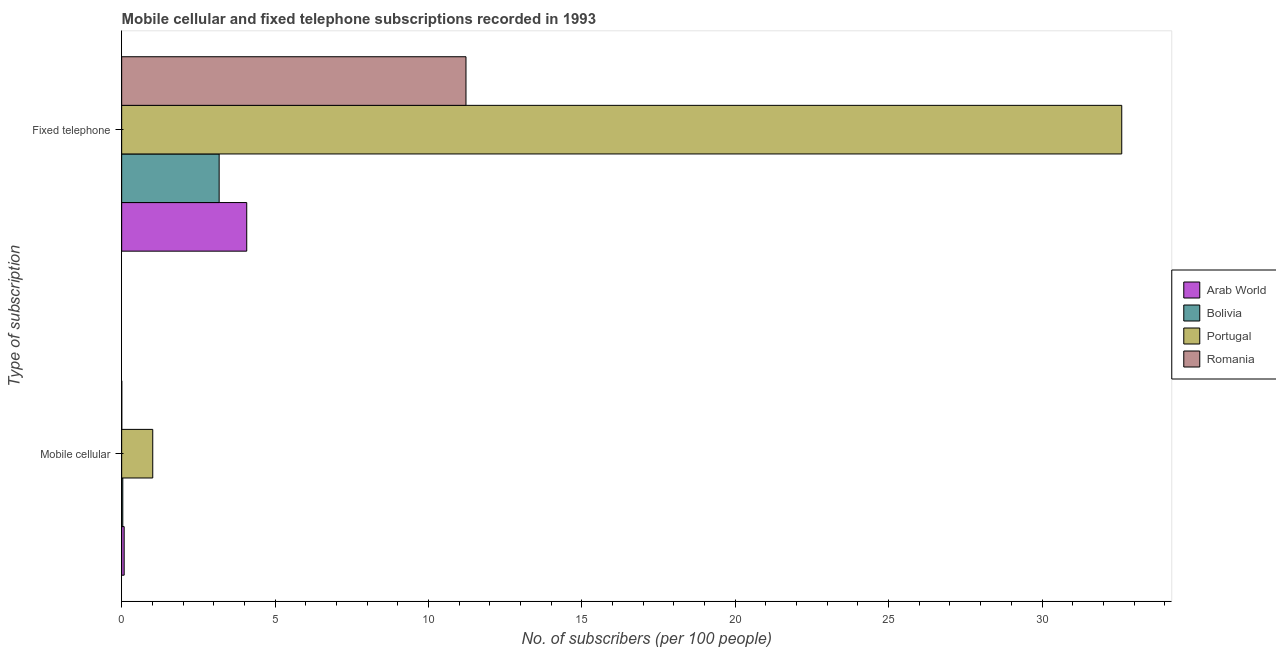Are the number of bars per tick equal to the number of legend labels?
Your response must be concise. Yes. How many bars are there on the 2nd tick from the bottom?
Provide a succinct answer. 4. What is the label of the 2nd group of bars from the top?
Your answer should be compact. Mobile cellular. What is the number of mobile cellular subscribers in Portugal?
Offer a terse response. 1.01. Across all countries, what is the maximum number of fixed telephone subscribers?
Give a very brief answer. 32.6. Across all countries, what is the minimum number of mobile cellular subscribers?
Give a very brief answer. 0. In which country was the number of fixed telephone subscribers maximum?
Give a very brief answer. Portugal. In which country was the number of mobile cellular subscribers minimum?
Ensure brevity in your answer.  Romania. What is the total number of fixed telephone subscribers in the graph?
Your answer should be very brief. 51.08. What is the difference between the number of mobile cellular subscribers in Bolivia and that in Portugal?
Keep it short and to the point. -0.98. What is the difference between the number of fixed telephone subscribers in Portugal and the number of mobile cellular subscribers in Arab World?
Give a very brief answer. 32.52. What is the average number of fixed telephone subscribers per country?
Provide a short and direct response. 12.77. What is the difference between the number of mobile cellular subscribers and number of fixed telephone subscribers in Romania?
Offer a very short reply. -11.22. What is the ratio of the number of fixed telephone subscribers in Bolivia to that in Portugal?
Offer a very short reply. 0.1. Is the number of mobile cellular subscribers in Bolivia less than that in Romania?
Make the answer very short. No. In how many countries, is the number of fixed telephone subscribers greater than the average number of fixed telephone subscribers taken over all countries?
Ensure brevity in your answer.  1. What does the 2nd bar from the top in Fixed telephone represents?
Provide a short and direct response. Portugal. What does the 4th bar from the bottom in Fixed telephone represents?
Ensure brevity in your answer.  Romania. How many bars are there?
Make the answer very short. 8. Are all the bars in the graph horizontal?
Provide a succinct answer. Yes. How many countries are there in the graph?
Your answer should be compact. 4. What is the difference between two consecutive major ticks on the X-axis?
Give a very brief answer. 5. Does the graph contain any zero values?
Give a very brief answer. No. Does the graph contain grids?
Keep it short and to the point. No. Where does the legend appear in the graph?
Provide a succinct answer. Center right. What is the title of the graph?
Your answer should be compact. Mobile cellular and fixed telephone subscriptions recorded in 1993. What is the label or title of the X-axis?
Give a very brief answer. No. of subscribers (per 100 people). What is the label or title of the Y-axis?
Your answer should be compact. Type of subscription. What is the No. of subscribers (per 100 people) of Arab World in Mobile cellular?
Offer a terse response. 0.08. What is the No. of subscribers (per 100 people) of Bolivia in Mobile cellular?
Provide a short and direct response. 0.04. What is the No. of subscribers (per 100 people) of Portugal in Mobile cellular?
Keep it short and to the point. 1.01. What is the No. of subscribers (per 100 people) in Romania in Mobile cellular?
Ensure brevity in your answer.  0. What is the No. of subscribers (per 100 people) in Arab World in Fixed telephone?
Your response must be concise. 4.08. What is the No. of subscribers (per 100 people) in Bolivia in Fixed telephone?
Your response must be concise. 3.18. What is the No. of subscribers (per 100 people) of Portugal in Fixed telephone?
Your response must be concise. 32.6. What is the No. of subscribers (per 100 people) in Romania in Fixed telephone?
Offer a terse response. 11.22. Across all Type of subscription, what is the maximum No. of subscribers (per 100 people) in Arab World?
Give a very brief answer. 4.08. Across all Type of subscription, what is the maximum No. of subscribers (per 100 people) of Bolivia?
Offer a very short reply. 3.18. Across all Type of subscription, what is the maximum No. of subscribers (per 100 people) of Portugal?
Your answer should be very brief. 32.6. Across all Type of subscription, what is the maximum No. of subscribers (per 100 people) in Romania?
Your answer should be very brief. 11.22. Across all Type of subscription, what is the minimum No. of subscribers (per 100 people) in Arab World?
Offer a terse response. 0.08. Across all Type of subscription, what is the minimum No. of subscribers (per 100 people) of Bolivia?
Make the answer very short. 0.04. Across all Type of subscription, what is the minimum No. of subscribers (per 100 people) of Portugal?
Ensure brevity in your answer.  1.01. Across all Type of subscription, what is the minimum No. of subscribers (per 100 people) of Romania?
Give a very brief answer. 0. What is the total No. of subscribers (per 100 people) in Arab World in the graph?
Your response must be concise. 4.16. What is the total No. of subscribers (per 100 people) in Bolivia in the graph?
Provide a succinct answer. 3.21. What is the total No. of subscribers (per 100 people) in Portugal in the graph?
Ensure brevity in your answer.  33.61. What is the total No. of subscribers (per 100 people) in Romania in the graph?
Offer a terse response. 11.23. What is the difference between the No. of subscribers (per 100 people) in Arab World in Mobile cellular and that in Fixed telephone?
Give a very brief answer. -4. What is the difference between the No. of subscribers (per 100 people) in Bolivia in Mobile cellular and that in Fixed telephone?
Offer a terse response. -3.14. What is the difference between the No. of subscribers (per 100 people) in Portugal in Mobile cellular and that in Fixed telephone?
Your response must be concise. -31.59. What is the difference between the No. of subscribers (per 100 people) of Romania in Mobile cellular and that in Fixed telephone?
Offer a very short reply. -11.22. What is the difference between the No. of subscribers (per 100 people) of Arab World in Mobile cellular and the No. of subscribers (per 100 people) of Bolivia in Fixed telephone?
Your answer should be very brief. -3.1. What is the difference between the No. of subscribers (per 100 people) in Arab World in Mobile cellular and the No. of subscribers (per 100 people) in Portugal in Fixed telephone?
Ensure brevity in your answer.  -32.52. What is the difference between the No. of subscribers (per 100 people) in Arab World in Mobile cellular and the No. of subscribers (per 100 people) in Romania in Fixed telephone?
Provide a succinct answer. -11.14. What is the difference between the No. of subscribers (per 100 people) in Bolivia in Mobile cellular and the No. of subscribers (per 100 people) in Portugal in Fixed telephone?
Offer a very short reply. -32.56. What is the difference between the No. of subscribers (per 100 people) in Bolivia in Mobile cellular and the No. of subscribers (per 100 people) in Romania in Fixed telephone?
Ensure brevity in your answer.  -11.19. What is the difference between the No. of subscribers (per 100 people) of Portugal in Mobile cellular and the No. of subscribers (per 100 people) of Romania in Fixed telephone?
Your answer should be compact. -10.21. What is the average No. of subscribers (per 100 people) of Arab World per Type of subscription?
Offer a very short reply. 2.08. What is the average No. of subscribers (per 100 people) of Bolivia per Type of subscription?
Make the answer very short. 1.61. What is the average No. of subscribers (per 100 people) of Portugal per Type of subscription?
Ensure brevity in your answer.  16.81. What is the average No. of subscribers (per 100 people) of Romania per Type of subscription?
Provide a short and direct response. 5.61. What is the difference between the No. of subscribers (per 100 people) of Arab World and No. of subscribers (per 100 people) of Bolivia in Mobile cellular?
Your answer should be very brief. 0.04. What is the difference between the No. of subscribers (per 100 people) of Arab World and No. of subscribers (per 100 people) of Portugal in Mobile cellular?
Give a very brief answer. -0.93. What is the difference between the No. of subscribers (per 100 people) in Arab World and No. of subscribers (per 100 people) in Romania in Mobile cellular?
Your answer should be compact. 0.08. What is the difference between the No. of subscribers (per 100 people) of Bolivia and No. of subscribers (per 100 people) of Portugal in Mobile cellular?
Offer a terse response. -0.98. What is the difference between the No. of subscribers (per 100 people) in Bolivia and No. of subscribers (per 100 people) in Romania in Mobile cellular?
Your response must be concise. 0.03. What is the difference between the No. of subscribers (per 100 people) of Portugal and No. of subscribers (per 100 people) of Romania in Mobile cellular?
Give a very brief answer. 1.01. What is the difference between the No. of subscribers (per 100 people) in Arab World and No. of subscribers (per 100 people) in Bolivia in Fixed telephone?
Provide a succinct answer. 0.9. What is the difference between the No. of subscribers (per 100 people) of Arab World and No. of subscribers (per 100 people) of Portugal in Fixed telephone?
Provide a short and direct response. -28.52. What is the difference between the No. of subscribers (per 100 people) of Arab World and No. of subscribers (per 100 people) of Romania in Fixed telephone?
Your answer should be compact. -7.15. What is the difference between the No. of subscribers (per 100 people) of Bolivia and No. of subscribers (per 100 people) of Portugal in Fixed telephone?
Offer a terse response. -29.42. What is the difference between the No. of subscribers (per 100 people) of Bolivia and No. of subscribers (per 100 people) of Romania in Fixed telephone?
Ensure brevity in your answer.  -8.05. What is the difference between the No. of subscribers (per 100 people) of Portugal and No. of subscribers (per 100 people) of Romania in Fixed telephone?
Keep it short and to the point. 21.38. What is the ratio of the No. of subscribers (per 100 people) of Arab World in Mobile cellular to that in Fixed telephone?
Provide a succinct answer. 0.02. What is the ratio of the No. of subscribers (per 100 people) of Bolivia in Mobile cellular to that in Fixed telephone?
Your answer should be compact. 0.01. What is the ratio of the No. of subscribers (per 100 people) of Portugal in Mobile cellular to that in Fixed telephone?
Provide a succinct answer. 0.03. What is the difference between the highest and the second highest No. of subscribers (per 100 people) of Arab World?
Give a very brief answer. 4. What is the difference between the highest and the second highest No. of subscribers (per 100 people) of Bolivia?
Provide a succinct answer. 3.14. What is the difference between the highest and the second highest No. of subscribers (per 100 people) in Portugal?
Give a very brief answer. 31.59. What is the difference between the highest and the second highest No. of subscribers (per 100 people) in Romania?
Keep it short and to the point. 11.22. What is the difference between the highest and the lowest No. of subscribers (per 100 people) of Arab World?
Make the answer very short. 4. What is the difference between the highest and the lowest No. of subscribers (per 100 people) of Bolivia?
Offer a very short reply. 3.14. What is the difference between the highest and the lowest No. of subscribers (per 100 people) in Portugal?
Your response must be concise. 31.59. What is the difference between the highest and the lowest No. of subscribers (per 100 people) of Romania?
Offer a very short reply. 11.22. 